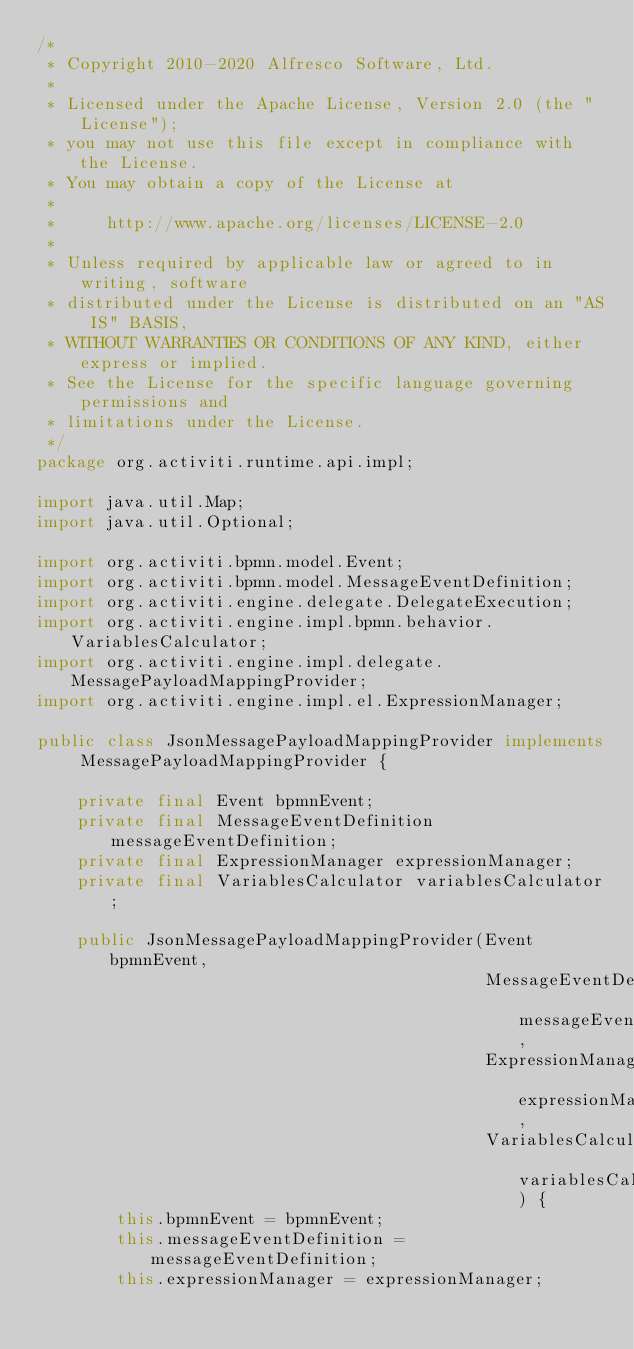<code> <loc_0><loc_0><loc_500><loc_500><_Java_>/*
 * Copyright 2010-2020 Alfresco Software, Ltd.
 *
 * Licensed under the Apache License, Version 2.0 (the "License");
 * you may not use this file except in compliance with the License.
 * You may obtain a copy of the License at
 *
 *     http://www.apache.org/licenses/LICENSE-2.0
 *
 * Unless required by applicable law or agreed to in writing, software
 * distributed under the License is distributed on an "AS IS" BASIS,
 * WITHOUT WARRANTIES OR CONDITIONS OF ANY KIND, either express or implied.
 * See the License for the specific language governing permissions and
 * limitations under the License.
 */
package org.activiti.runtime.api.impl;

import java.util.Map;
import java.util.Optional;

import org.activiti.bpmn.model.Event;
import org.activiti.bpmn.model.MessageEventDefinition;
import org.activiti.engine.delegate.DelegateExecution;
import org.activiti.engine.impl.bpmn.behavior.VariablesCalculator;
import org.activiti.engine.impl.delegate.MessagePayloadMappingProvider;
import org.activiti.engine.impl.el.ExpressionManager;

public class JsonMessagePayloadMappingProvider implements MessagePayloadMappingProvider {

    private final Event bpmnEvent;
    private final MessageEventDefinition messageEventDefinition;
    private final ExpressionManager expressionManager;
    private final VariablesCalculator variablesCalculator;

    public JsonMessagePayloadMappingProvider(Event bpmnEvent,
                                             MessageEventDefinition messageEventDefinition,
                                             ExpressionManager expressionManager,
                                             VariablesCalculator variablesCalculator) {
        this.bpmnEvent = bpmnEvent;
        this.messageEventDefinition = messageEventDefinition;
        this.expressionManager = expressionManager;</code> 